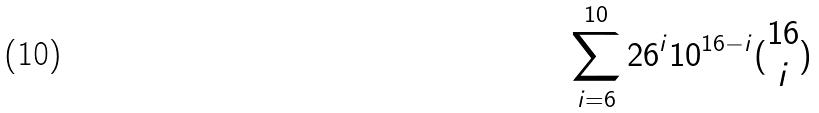Convert formula to latex. <formula><loc_0><loc_0><loc_500><loc_500>\sum _ { i = 6 } ^ { 1 0 } 2 6 ^ { i } 1 0 ^ { 1 6 - i } ( \begin{matrix} 1 6 \\ i \end{matrix} )</formula> 